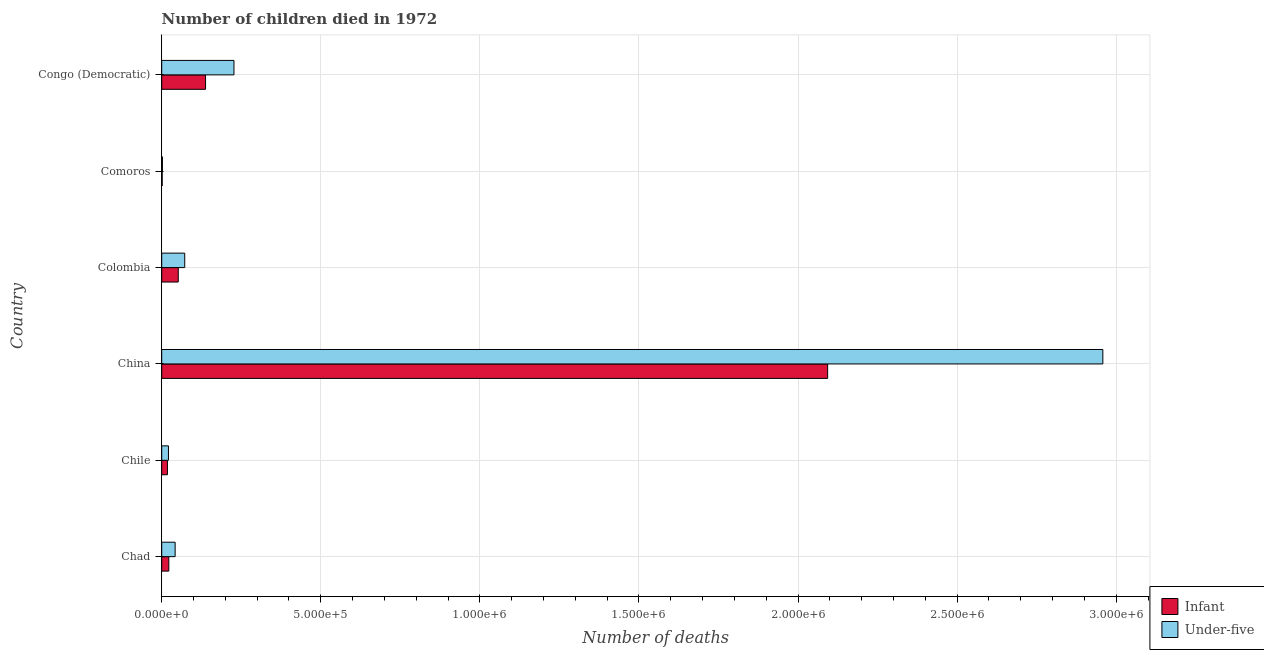How many different coloured bars are there?
Provide a succinct answer. 2. How many groups of bars are there?
Offer a terse response. 6. Are the number of bars on each tick of the Y-axis equal?
Your answer should be very brief. Yes. How many bars are there on the 5th tick from the bottom?
Offer a terse response. 2. What is the label of the 2nd group of bars from the top?
Offer a terse response. Comoros. What is the number of infant deaths in China?
Your answer should be very brief. 2.09e+06. Across all countries, what is the maximum number of infant deaths?
Keep it short and to the point. 2.09e+06. Across all countries, what is the minimum number of under-five deaths?
Make the answer very short. 2228. In which country was the number of under-five deaths minimum?
Your answer should be very brief. Comoros. What is the total number of infant deaths in the graph?
Make the answer very short. 2.32e+06. What is the difference between the number of under-five deaths in China and that in Colombia?
Offer a very short reply. 2.89e+06. What is the difference between the number of under-five deaths in Congo (Democratic) and the number of infant deaths in Chile?
Offer a terse response. 2.09e+05. What is the average number of infant deaths per country?
Offer a very short reply. 3.87e+05. What is the difference between the number of infant deaths and number of under-five deaths in Chile?
Provide a succinct answer. -3207. In how many countries, is the number of under-five deaths greater than 100000 ?
Provide a succinct answer. 2. What is the ratio of the number of under-five deaths in Chile to that in China?
Provide a succinct answer. 0.01. Is the number of infant deaths in Chile less than that in Colombia?
Give a very brief answer. Yes. Is the difference between the number of infant deaths in Chile and Colombia greater than the difference between the number of under-five deaths in Chile and Colombia?
Give a very brief answer. Yes. What is the difference between the highest and the second highest number of under-five deaths?
Ensure brevity in your answer.  2.73e+06. What is the difference between the highest and the lowest number of infant deaths?
Your answer should be compact. 2.09e+06. In how many countries, is the number of infant deaths greater than the average number of infant deaths taken over all countries?
Offer a very short reply. 1. What does the 2nd bar from the top in Colombia represents?
Make the answer very short. Infant. What does the 1st bar from the bottom in Congo (Democratic) represents?
Your answer should be very brief. Infant. Are all the bars in the graph horizontal?
Keep it short and to the point. Yes. How many countries are there in the graph?
Give a very brief answer. 6. What is the difference between two consecutive major ticks on the X-axis?
Provide a short and direct response. 5.00e+05. Are the values on the major ticks of X-axis written in scientific E-notation?
Ensure brevity in your answer.  Yes. Does the graph contain grids?
Offer a terse response. Yes. What is the title of the graph?
Ensure brevity in your answer.  Number of children died in 1972. What is the label or title of the X-axis?
Your answer should be compact. Number of deaths. What is the label or title of the Y-axis?
Your answer should be compact. Country. What is the Number of deaths in Infant in Chad?
Offer a very short reply. 2.23e+04. What is the Number of deaths of Under-five in Chad?
Provide a short and direct response. 4.22e+04. What is the Number of deaths of Infant in Chile?
Give a very brief answer. 1.80e+04. What is the Number of deaths of Under-five in Chile?
Make the answer very short. 2.12e+04. What is the Number of deaths of Infant in China?
Offer a terse response. 2.09e+06. What is the Number of deaths of Under-five in China?
Make the answer very short. 2.96e+06. What is the Number of deaths of Infant in Colombia?
Provide a succinct answer. 5.20e+04. What is the Number of deaths in Under-five in Colombia?
Your answer should be very brief. 7.24e+04. What is the Number of deaths of Infant in Comoros?
Your answer should be very brief. 1491. What is the Number of deaths in Under-five in Comoros?
Keep it short and to the point. 2228. What is the Number of deaths of Infant in Congo (Democratic)?
Offer a very short reply. 1.38e+05. What is the Number of deaths of Under-five in Congo (Democratic)?
Provide a succinct answer. 2.27e+05. Across all countries, what is the maximum Number of deaths in Infant?
Ensure brevity in your answer.  2.09e+06. Across all countries, what is the maximum Number of deaths in Under-five?
Your answer should be compact. 2.96e+06. Across all countries, what is the minimum Number of deaths in Infant?
Provide a succinct answer. 1491. Across all countries, what is the minimum Number of deaths in Under-five?
Ensure brevity in your answer.  2228. What is the total Number of deaths of Infant in the graph?
Ensure brevity in your answer.  2.32e+06. What is the total Number of deaths in Under-five in the graph?
Offer a very short reply. 3.32e+06. What is the difference between the Number of deaths of Infant in Chad and that in Chile?
Offer a very short reply. 4330. What is the difference between the Number of deaths in Under-five in Chad and that in Chile?
Keep it short and to the point. 2.10e+04. What is the difference between the Number of deaths in Infant in Chad and that in China?
Your answer should be very brief. -2.07e+06. What is the difference between the Number of deaths of Under-five in Chad and that in China?
Your answer should be very brief. -2.92e+06. What is the difference between the Number of deaths in Infant in Chad and that in Colombia?
Offer a terse response. -2.96e+04. What is the difference between the Number of deaths of Under-five in Chad and that in Colombia?
Your response must be concise. -3.01e+04. What is the difference between the Number of deaths of Infant in Chad and that in Comoros?
Offer a very short reply. 2.08e+04. What is the difference between the Number of deaths of Under-five in Chad and that in Comoros?
Your answer should be very brief. 4.00e+04. What is the difference between the Number of deaths in Infant in Chad and that in Congo (Democratic)?
Your response must be concise. -1.15e+05. What is the difference between the Number of deaths in Under-five in Chad and that in Congo (Democratic)?
Give a very brief answer. -1.85e+05. What is the difference between the Number of deaths in Infant in Chile and that in China?
Offer a terse response. -2.08e+06. What is the difference between the Number of deaths in Under-five in Chile and that in China?
Your response must be concise. -2.94e+06. What is the difference between the Number of deaths of Infant in Chile and that in Colombia?
Make the answer very short. -3.40e+04. What is the difference between the Number of deaths of Under-five in Chile and that in Colombia?
Make the answer very short. -5.11e+04. What is the difference between the Number of deaths in Infant in Chile and that in Comoros?
Offer a terse response. 1.65e+04. What is the difference between the Number of deaths in Under-five in Chile and that in Comoros?
Keep it short and to the point. 1.90e+04. What is the difference between the Number of deaths of Infant in Chile and that in Congo (Democratic)?
Your answer should be very brief. -1.20e+05. What is the difference between the Number of deaths of Under-five in Chile and that in Congo (Democratic)?
Keep it short and to the point. -2.06e+05. What is the difference between the Number of deaths in Infant in China and that in Colombia?
Your response must be concise. 2.04e+06. What is the difference between the Number of deaths of Under-five in China and that in Colombia?
Offer a terse response. 2.89e+06. What is the difference between the Number of deaths in Infant in China and that in Comoros?
Make the answer very short. 2.09e+06. What is the difference between the Number of deaths of Under-five in China and that in Comoros?
Make the answer very short. 2.96e+06. What is the difference between the Number of deaths of Infant in China and that in Congo (Democratic)?
Keep it short and to the point. 1.96e+06. What is the difference between the Number of deaths of Under-five in China and that in Congo (Democratic)?
Provide a succinct answer. 2.73e+06. What is the difference between the Number of deaths in Infant in Colombia and that in Comoros?
Give a very brief answer. 5.05e+04. What is the difference between the Number of deaths in Under-five in Colombia and that in Comoros?
Keep it short and to the point. 7.01e+04. What is the difference between the Number of deaths in Infant in Colombia and that in Congo (Democratic)?
Provide a succinct answer. -8.58e+04. What is the difference between the Number of deaths in Under-five in Colombia and that in Congo (Democratic)?
Your response must be concise. -1.55e+05. What is the difference between the Number of deaths of Infant in Comoros and that in Congo (Democratic)?
Keep it short and to the point. -1.36e+05. What is the difference between the Number of deaths in Under-five in Comoros and that in Congo (Democratic)?
Keep it short and to the point. -2.25e+05. What is the difference between the Number of deaths of Infant in Chad and the Number of deaths of Under-five in Chile?
Your answer should be very brief. 1123. What is the difference between the Number of deaths of Infant in Chad and the Number of deaths of Under-five in China?
Offer a terse response. -2.94e+06. What is the difference between the Number of deaths of Infant in Chad and the Number of deaths of Under-five in Colombia?
Offer a very short reply. -5.00e+04. What is the difference between the Number of deaths in Infant in Chad and the Number of deaths in Under-five in Comoros?
Make the answer very short. 2.01e+04. What is the difference between the Number of deaths of Infant in Chad and the Number of deaths of Under-five in Congo (Democratic)?
Keep it short and to the point. -2.05e+05. What is the difference between the Number of deaths in Infant in Chile and the Number of deaths in Under-five in China?
Your answer should be very brief. -2.94e+06. What is the difference between the Number of deaths in Infant in Chile and the Number of deaths in Under-five in Colombia?
Your response must be concise. -5.44e+04. What is the difference between the Number of deaths of Infant in Chile and the Number of deaths of Under-five in Comoros?
Keep it short and to the point. 1.58e+04. What is the difference between the Number of deaths in Infant in Chile and the Number of deaths in Under-five in Congo (Democratic)?
Your answer should be very brief. -2.09e+05. What is the difference between the Number of deaths of Infant in China and the Number of deaths of Under-five in Colombia?
Keep it short and to the point. 2.02e+06. What is the difference between the Number of deaths in Infant in China and the Number of deaths in Under-five in Comoros?
Your answer should be compact. 2.09e+06. What is the difference between the Number of deaths of Infant in China and the Number of deaths of Under-five in Congo (Democratic)?
Your answer should be very brief. 1.87e+06. What is the difference between the Number of deaths in Infant in Colombia and the Number of deaths in Under-five in Comoros?
Keep it short and to the point. 4.97e+04. What is the difference between the Number of deaths of Infant in Colombia and the Number of deaths of Under-five in Congo (Democratic)?
Your answer should be compact. -1.75e+05. What is the difference between the Number of deaths of Infant in Comoros and the Number of deaths of Under-five in Congo (Democratic)?
Give a very brief answer. -2.26e+05. What is the average Number of deaths in Infant per country?
Ensure brevity in your answer.  3.87e+05. What is the average Number of deaths of Under-five per country?
Ensure brevity in your answer.  5.54e+05. What is the difference between the Number of deaths of Infant and Number of deaths of Under-five in Chad?
Your answer should be compact. -1.99e+04. What is the difference between the Number of deaths of Infant and Number of deaths of Under-five in Chile?
Your answer should be compact. -3207. What is the difference between the Number of deaths of Infant and Number of deaths of Under-five in China?
Provide a succinct answer. -8.65e+05. What is the difference between the Number of deaths of Infant and Number of deaths of Under-five in Colombia?
Your answer should be very brief. -2.04e+04. What is the difference between the Number of deaths of Infant and Number of deaths of Under-five in Comoros?
Offer a terse response. -737. What is the difference between the Number of deaths in Infant and Number of deaths in Under-five in Congo (Democratic)?
Offer a very short reply. -8.93e+04. What is the ratio of the Number of deaths of Infant in Chad to that in Chile?
Offer a very short reply. 1.24. What is the ratio of the Number of deaths of Under-five in Chad to that in Chile?
Ensure brevity in your answer.  1.99. What is the ratio of the Number of deaths in Infant in Chad to that in China?
Provide a short and direct response. 0.01. What is the ratio of the Number of deaths in Under-five in Chad to that in China?
Your response must be concise. 0.01. What is the ratio of the Number of deaths in Infant in Chad to that in Colombia?
Your answer should be compact. 0.43. What is the ratio of the Number of deaths of Under-five in Chad to that in Colombia?
Your answer should be compact. 0.58. What is the ratio of the Number of deaths of Infant in Chad to that in Comoros?
Make the answer very short. 14.98. What is the ratio of the Number of deaths of Under-five in Chad to that in Comoros?
Provide a short and direct response. 18.94. What is the ratio of the Number of deaths of Infant in Chad to that in Congo (Democratic)?
Offer a very short reply. 0.16. What is the ratio of the Number of deaths in Under-five in Chad to that in Congo (Democratic)?
Make the answer very short. 0.19. What is the ratio of the Number of deaths of Infant in Chile to that in China?
Give a very brief answer. 0.01. What is the ratio of the Number of deaths of Under-five in Chile to that in China?
Your response must be concise. 0.01. What is the ratio of the Number of deaths in Infant in Chile to that in Colombia?
Your response must be concise. 0.35. What is the ratio of the Number of deaths of Under-five in Chile to that in Colombia?
Your response must be concise. 0.29. What is the ratio of the Number of deaths in Infant in Chile to that in Comoros?
Make the answer very short. 12.07. What is the ratio of the Number of deaths in Under-five in Chile to that in Comoros?
Give a very brief answer. 9.52. What is the ratio of the Number of deaths of Infant in Chile to that in Congo (Democratic)?
Your response must be concise. 0.13. What is the ratio of the Number of deaths in Under-five in Chile to that in Congo (Democratic)?
Your answer should be very brief. 0.09. What is the ratio of the Number of deaths of Infant in China to that in Colombia?
Your response must be concise. 40.27. What is the ratio of the Number of deaths in Under-five in China to that in Colombia?
Your response must be concise. 40.88. What is the ratio of the Number of deaths of Infant in China to that in Comoros?
Your response must be concise. 1403.8. What is the ratio of the Number of deaths in Under-five in China to that in Comoros?
Provide a short and direct response. 1327.67. What is the ratio of the Number of deaths of Infant in China to that in Congo (Democratic)?
Your answer should be compact. 15.19. What is the ratio of the Number of deaths of Under-five in China to that in Congo (Democratic)?
Offer a very short reply. 13.03. What is the ratio of the Number of deaths of Infant in Colombia to that in Comoros?
Ensure brevity in your answer.  34.86. What is the ratio of the Number of deaths of Under-five in Colombia to that in Comoros?
Your answer should be very brief. 32.47. What is the ratio of the Number of deaths in Infant in Colombia to that in Congo (Democratic)?
Make the answer very short. 0.38. What is the ratio of the Number of deaths of Under-five in Colombia to that in Congo (Democratic)?
Make the answer very short. 0.32. What is the ratio of the Number of deaths of Infant in Comoros to that in Congo (Democratic)?
Give a very brief answer. 0.01. What is the ratio of the Number of deaths in Under-five in Comoros to that in Congo (Democratic)?
Your answer should be very brief. 0.01. What is the difference between the highest and the second highest Number of deaths in Infant?
Provide a short and direct response. 1.96e+06. What is the difference between the highest and the second highest Number of deaths of Under-five?
Provide a succinct answer. 2.73e+06. What is the difference between the highest and the lowest Number of deaths in Infant?
Your answer should be very brief. 2.09e+06. What is the difference between the highest and the lowest Number of deaths in Under-five?
Make the answer very short. 2.96e+06. 